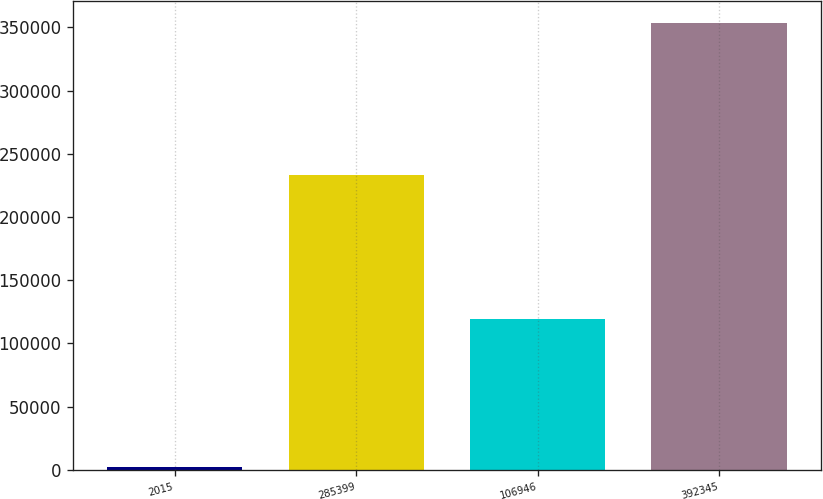<chart> <loc_0><loc_0><loc_500><loc_500><bar_chart><fcel>2015<fcel>285399<fcel>106946<fcel>392345<nl><fcel>2013<fcel>233530<fcel>119599<fcel>353129<nl></chart> 